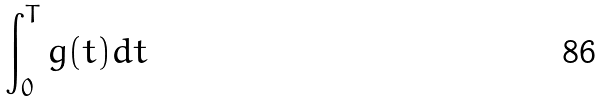<formula> <loc_0><loc_0><loc_500><loc_500>\int _ { 0 } ^ { T } g ( t ) d t</formula> 